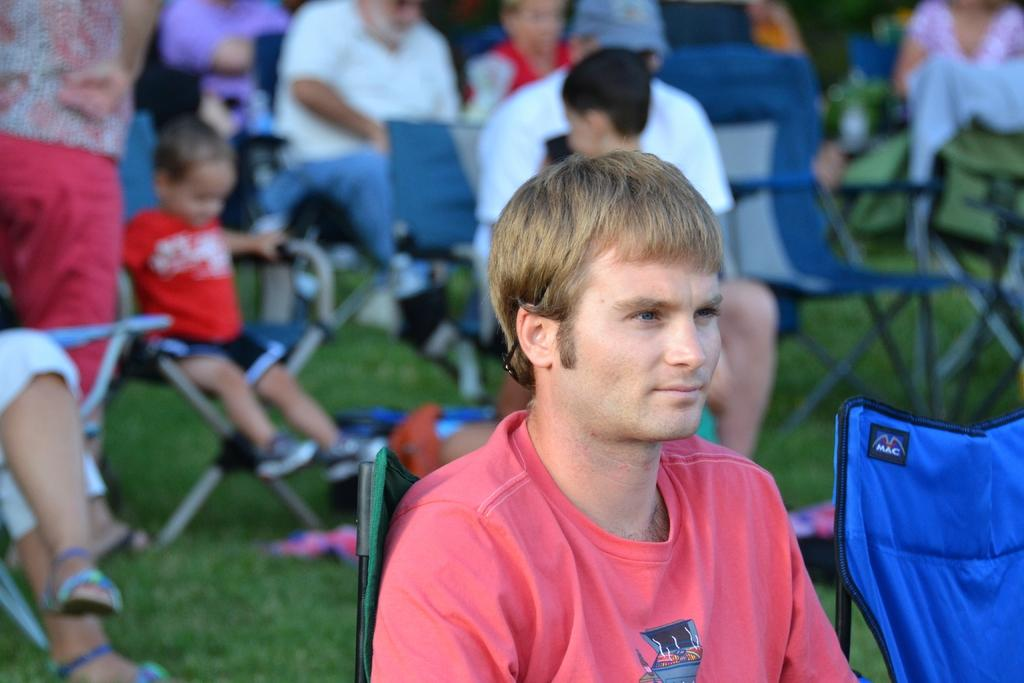Who is present in the image? There is a person in the image. What is the person wearing? The person is wearing a red T-shirt. What is the person doing in the image? The person is sitting on a chair. Can you describe the other persons in the image? There are other persons in the background of the image, and they are also sitting on chairs. What type of paint is being used by the person in the image? There is no paint or painting activity present in the image. 